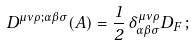<formula> <loc_0><loc_0><loc_500><loc_500>D ^ { \mu \nu \rho ; \alpha \beta \sigma } ( A ) = \frac { 1 } { 2 } \, \delta ^ { \mu \nu \rho } _ { \alpha \beta \sigma } D _ { F } \, ;</formula> 